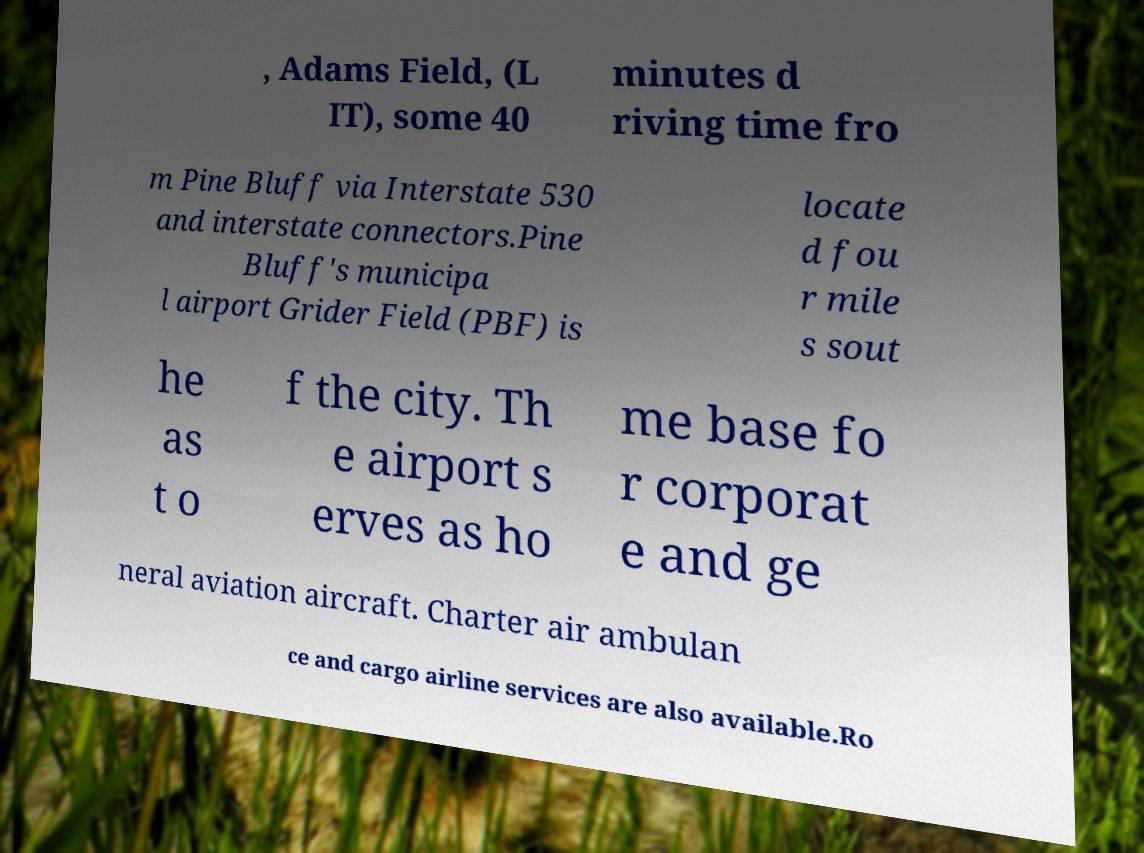Can you accurately transcribe the text from the provided image for me? , Adams Field, (L IT), some 40 minutes d riving time fro m Pine Bluff via Interstate 530 and interstate connectors.Pine Bluff's municipa l airport Grider Field (PBF) is locate d fou r mile s sout he as t o f the city. Th e airport s erves as ho me base fo r corporat e and ge neral aviation aircraft. Charter air ambulan ce and cargo airline services are also available.Ro 